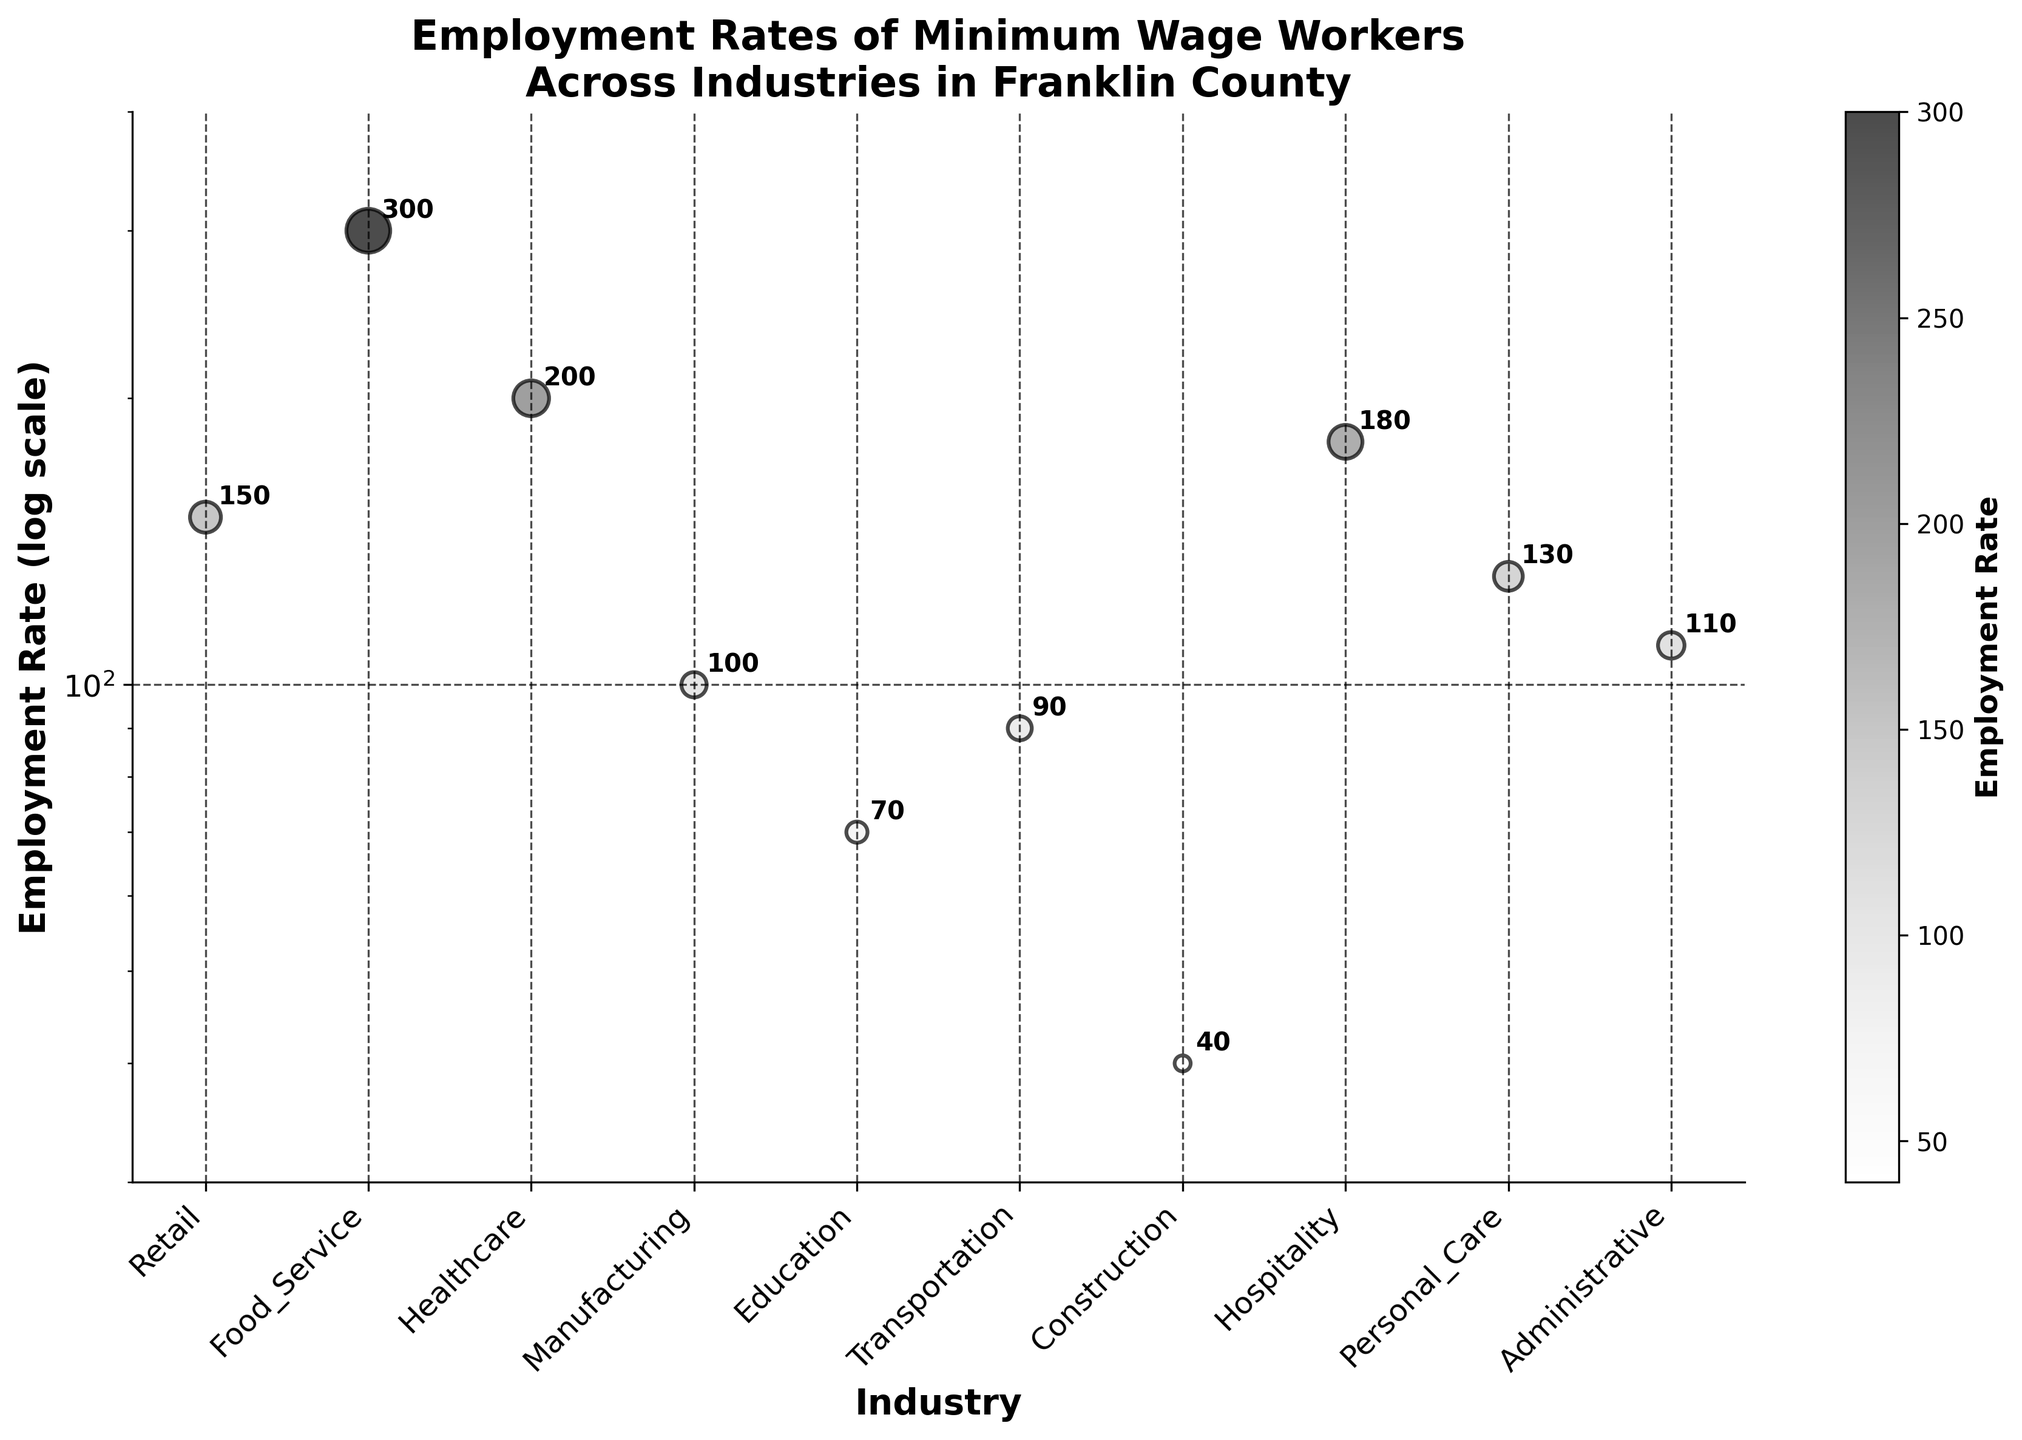What is the title of the figure? The title of the chart is usually displayed at the top. In this case, it is "Employment Rates of Minimum Wage Workers Across Industries in Franklin County".
Answer: Employment Rates of Minimum Wage Workers Across Industries in Franklin County Which industry has the highest employment rate? By looking at the y-axis values and the plotted points, the one with the highest employment rate is the one with the highest point. In this case, it is Food_Service at 300.
Answer: Food_Service Which industry has the lowest employment rate? By looking at the y-axis and the data points, the one with the lowest employment rate is the one closest to the bottom. Here, it is Construction at 40.
Answer: Construction What is the employment rate for the Healthcare industry? The employment rate for the Healthcare industry is indicated by the y-axis value of the data point labeled Healthcare. It's 200.
Answer: 200 How many industries have an employment rate above 100? There are six industries above the 100 mark on the y-axis: Retail, Food_Service, Healthcare, Hospitality, Personal_Care, and Administrative.
Answer: Six What is the difference in employment rates between Retail and Hospitality? The employment rate of Retail is 150, and Hospitality is 180. The difference is 180 - 150 = 30.
Answer: 30 What is the employment rate range across all industries? The highest employment rate is 300 (Food_Service), and the lowest is 40 (Construction). Therefore, the range is 300 - 40.
Answer: 260 Which industry has a similar employment rate to Personal_Care? The employment rate for Personal_Care is 130. The closest point is Retail, with an employment rate of 150.
Answer: Retail Calculate the average employment rate of the listed industries. Adding all employment rates: 150 + 300 + 200 + 100 + 70 + 90 + 40 + 180 + 130 + 110 = 1370. Dividing by the number of industries (10), the average is 1370 / 10 = 137.
Answer: 137 Are there more industries with employment rates below or above 100? Counting the points: Below 100, there are three (Manufacturing, Education, Construction); above 100, there are seven. So, more industries have employment rates above 100.
Answer: Above 